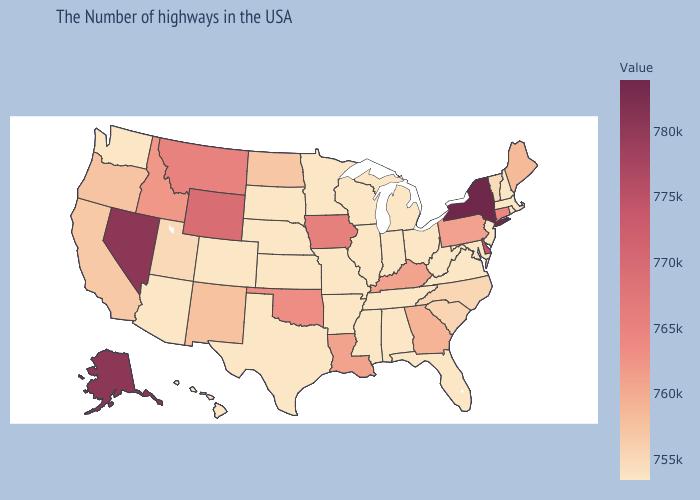Does the map have missing data?
Be succinct. No. Among the states that border Oregon , which have the lowest value?
Quick response, please. Washington. Which states have the lowest value in the South?
Quick response, please. Virginia, West Virginia, Florida, Alabama, Tennessee, Mississippi, Arkansas, Texas. Among the states that border Wyoming , which have the highest value?
Answer briefly. Montana. Among the states that border New Mexico , which have the lowest value?
Quick response, please. Texas, Colorado, Arizona. Among the states that border Pennsylvania , does Ohio have the highest value?
Keep it brief. No. 